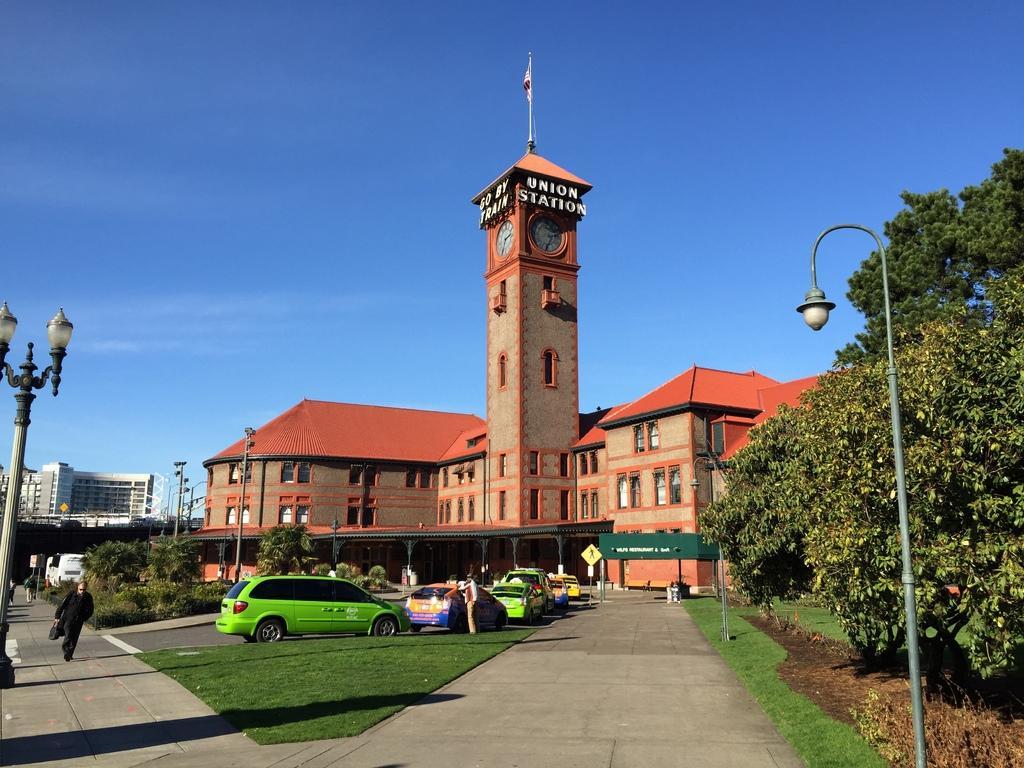How would you summarize this image in a sentence or two? In this image we can see a clock tower, flag, flag post, buildings, street poles, street lights, motor vehicles, persons standing on the road, sign boards, trees and sky in the background. 